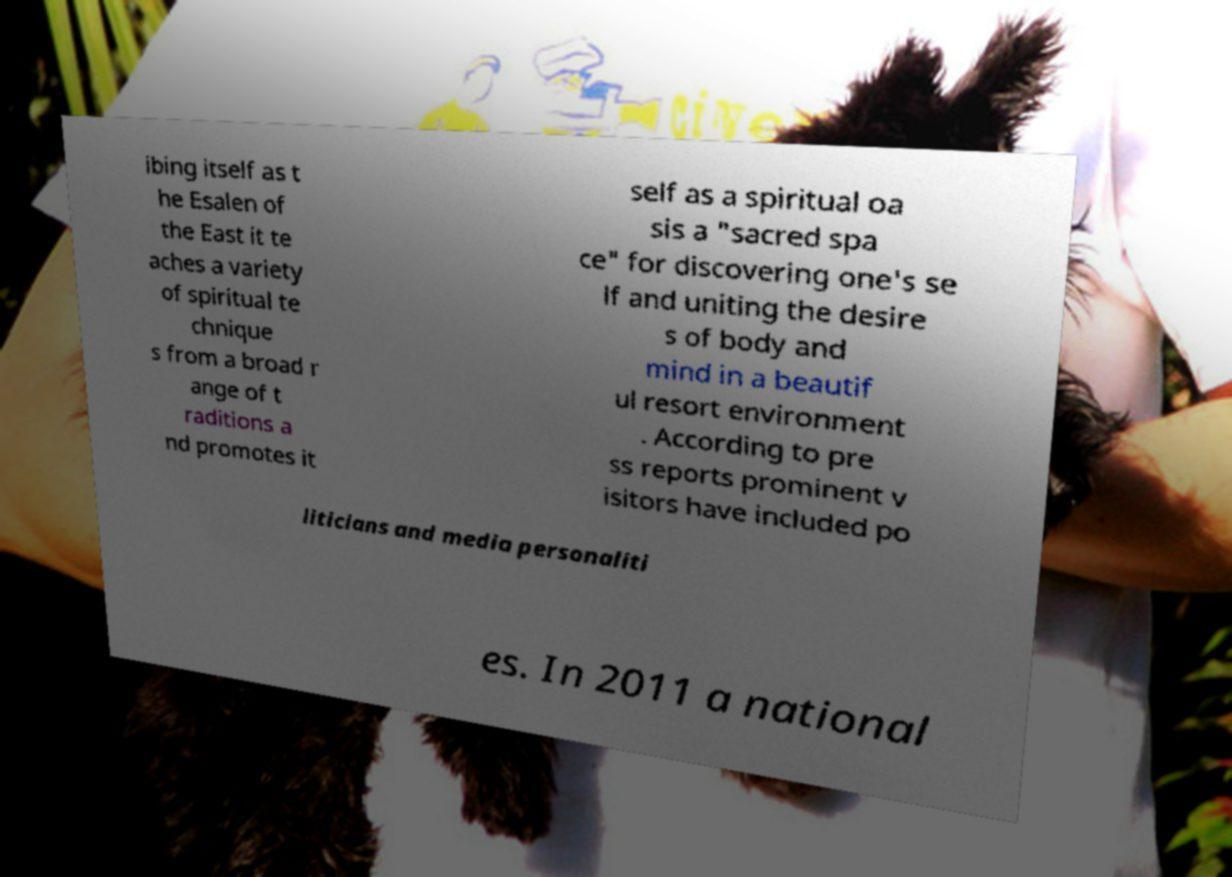Please identify and transcribe the text found in this image. ibing itself as t he Esalen of the East it te aches a variety of spiritual te chnique s from a broad r ange of t raditions a nd promotes it self as a spiritual oa sis a "sacred spa ce" for discovering one's se lf and uniting the desire s of body and mind in a beautif ul resort environment . According to pre ss reports prominent v isitors have included po liticians and media personaliti es. In 2011 a national 